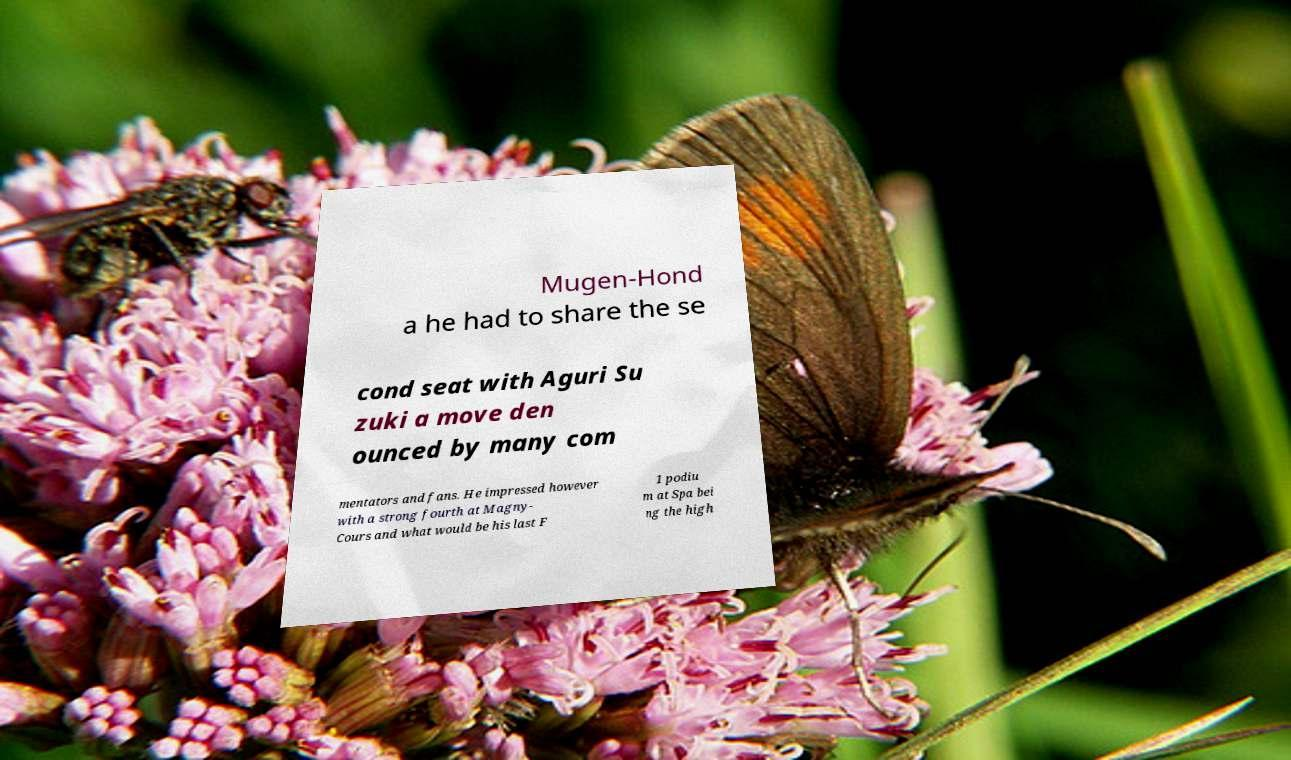I need the written content from this picture converted into text. Can you do that? Mugen-Hond a he had to share the se cond seat with Aguri Su zuki a move den ounced by many com mentators and fans. He impressed however with a strong fourth at Magny- Cours and what would be his last F 1 podiu m at Spa bei ng the high 